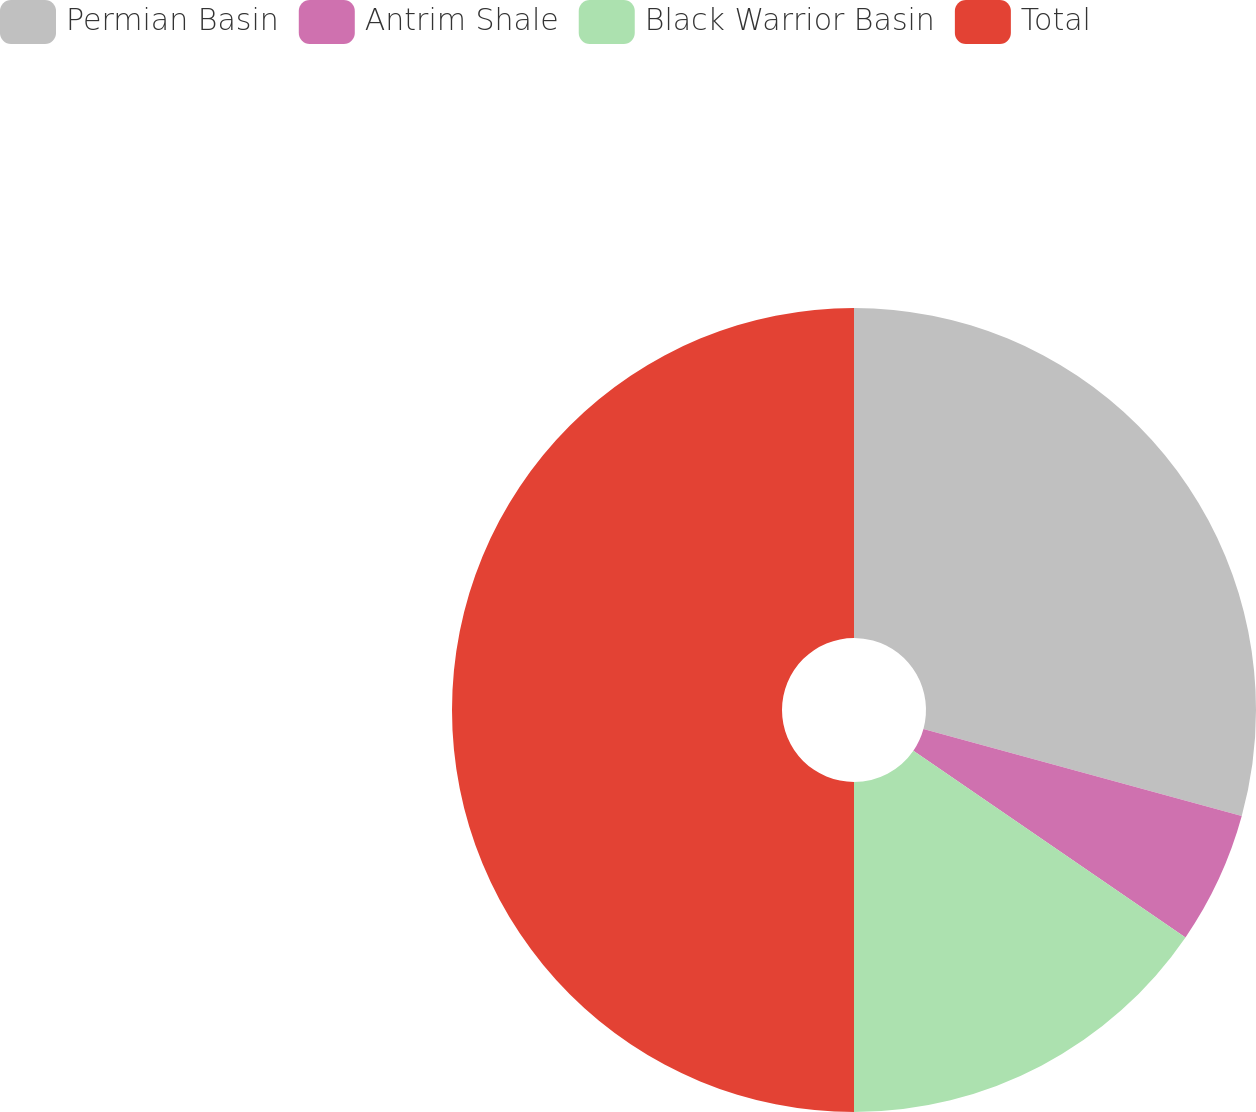Convert chart. <chart><loc_0><loc_0><loc_500><loc_500><pie_chart><fcel>Permian Basin<fcel>Antrim Shale<fcel>Black Warrior Basin<fcel>Total<nl><fcel>29.25%<fcel>5.32%<fcel>15.43%<fcel>50.0%<nl></chart> 